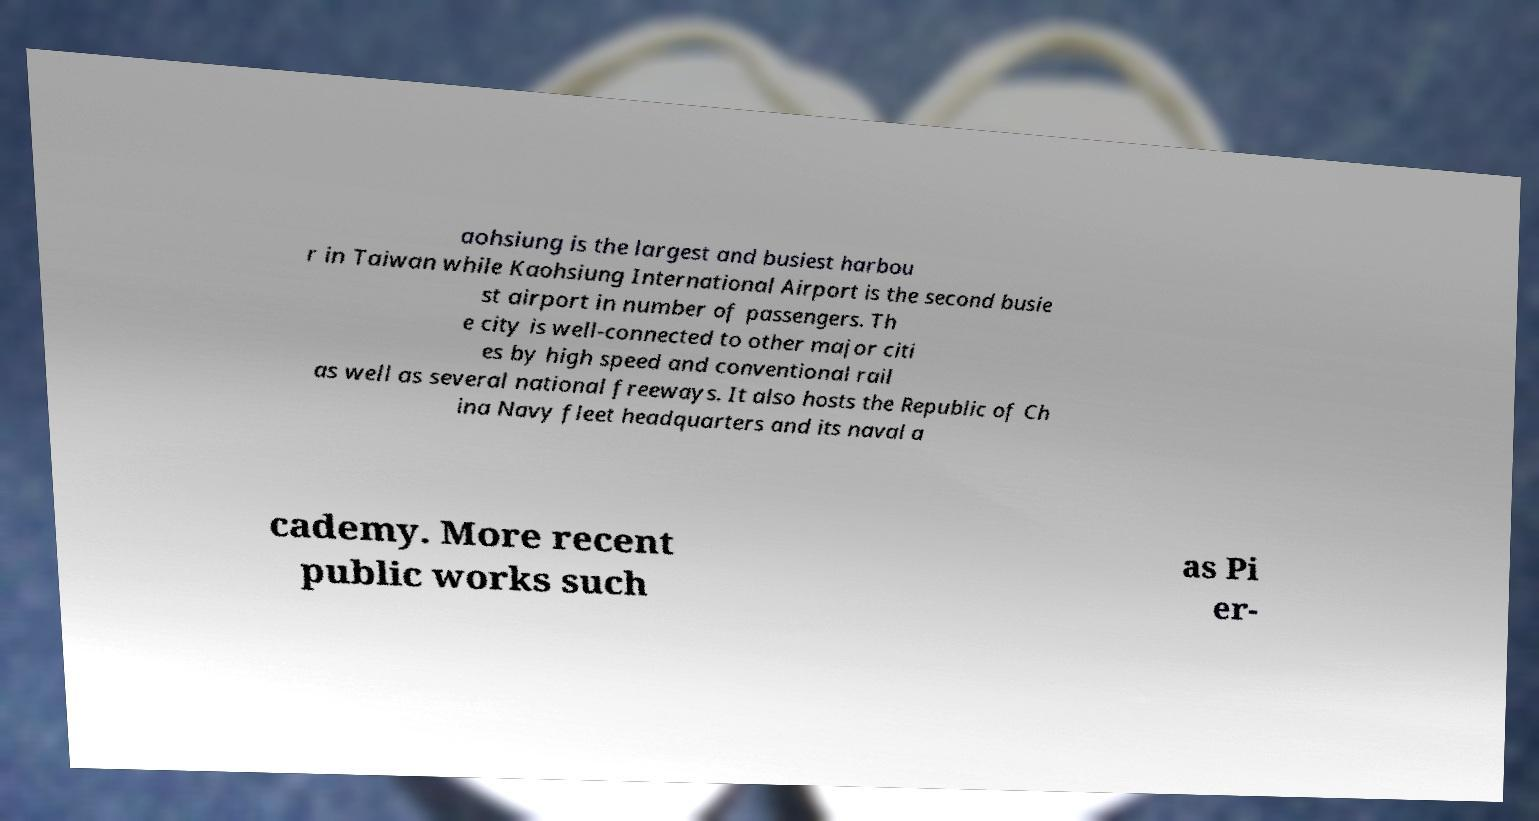For documentation purposes, I need the text within this image transcribed. Could you provide that? aohsiung is the largest and busiest harbou r in Taiwan while Kaohsiung International Airport is the second busie st airport in number of passengers. Th e city is well-connected to other major citi es by high speed and conventional rail as well as several national freeways. It also hosts the Republic of Ch ina Navy fleet headquarters and its naval a cademy. More recent public works such as Pi er- 